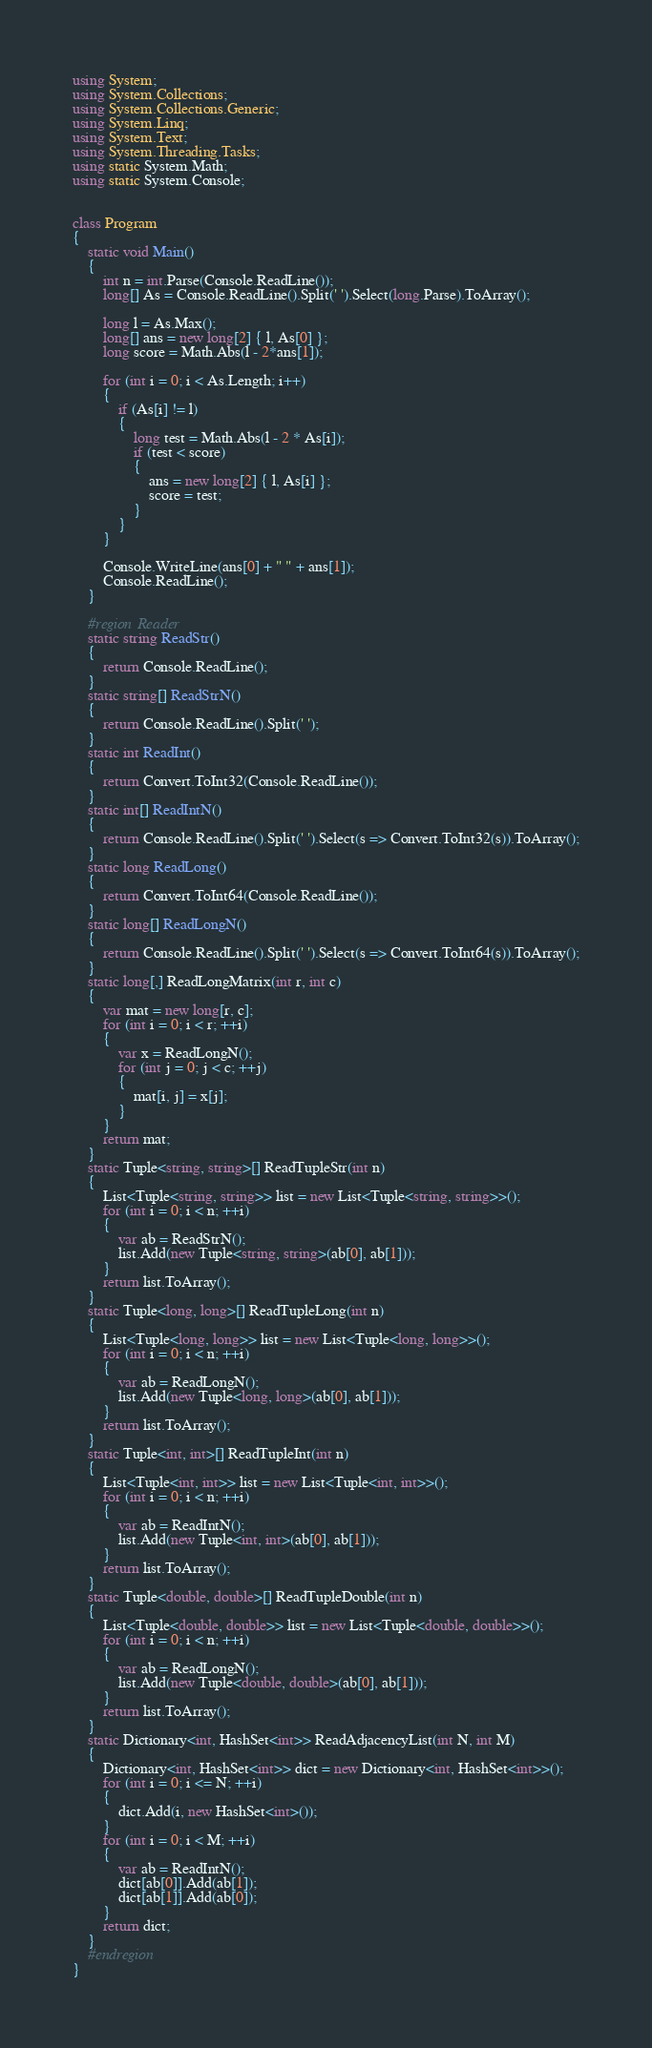Convert code to text. <code><loc_0><loc_0><loc_500><loc_500><_C#_>using System;
using System.Collections;
using System.Collections.Generic;
using System.Linq;
using System.Text;
using System.Threading.Tasks;
using static System.Math;
using static System.Console;


class Program
{
    static void Main()
    {
        int n = int.Parse(Console.ReadLine());
        long[] As = Console.ReadLine().Split(' ').Select(long.Parse).ToArray();

        long l = As.Max();
        long[] ans = new long[2] { l, As[0] };
        long score = Math.Abs(l - 2*ans[1]);

        for (int i = 0; i < As.Length; i++)
        {
            if (As[i] != l)
            {
                long test = Math.Abs(l - 2 * As[i]);
                if (test < score)
                {
                    ans = new long[2] { l, As[i] };
                    score = test;
                }
            }
        }

        Console.WriteLine(ans[0] + " " + ans[1]);
        Console.ReadLine();
    }

    #region Reader
    static string ReadStr()
    {
        return Console.ReadLine();
    }
    static string[] ReadStrN()
    {
        return Console.ReadLine().Split(' ');
    }
    static int ReadInt()
    {
        return Convert.ToInt32(Console.ReadLine());
    }
    static int[] ReadIntN()
    {
        return Console.ReadLine().Split(' ').Select(s => Convert.ToInt32(s)).ToArray();
    }
    static long ReadLong()
    {
        return Convert.ToInt64(Console.ReadLine());
    }
    static long[] ReadLongN()
    {
        return Console.ReadLine().Split(' ').Select(s => Convert.ToInt64(s)).ToArray();
    }
    static long[,] ReadLongMatrix(int r, int c)
    {
        var mat = new long[r, c];
        for (int i = 0; i < r; ++i)
        {
            var x = ReadLongN();
            for (int j = 0; j < c; ++j)
            {
                mat[i, j] = x[j];
            }
        }
        return mat;
    }
    static Tuple<string, string>[] ReadTupleStr(int n)
    {
        List<Tuple<string, string>> list = new List<Tuple<string, string>>();
        for (int i = 0; i < n; ++i)
        {
            var ab = ReadStrN();
            list.Add(new Tuple<string, string>(ab[0], ab[1]));
        }
        return list.ToArray();
    }
    static Tuple<long, long>[] ReadTupleLong(int n)
    {
        List<Tuple<long, long>> list = new List<Tuple<long, long>>();
        for (int i = 0; i < n; ++i)
        {
            var ab = ReadLongN();
            list.Add(new Tuple<long, long>(ab[0], ab[1]));
        }
        return list.ToArray();
    }
    static Tuple<int, int>[] ReadTupleInt(int n)
    {
        List<Tuple<int, int>> list = new List<Tuple<int, int>>();
        for (int i = 0; i < n; ++i)
        {
            var ab = ReadIntN();
            list.Add(new Tuple<int, int>(ab[0], ab[1]));
        }
        return list.ToArray();
    }
    static Tuple<double, double>[] ReadTupleDouble(int n)
    {
        List<Tuple<double, double>> list = new List<Tuple<double, double>>();
        for (int i = 0; i < n; ++i)
        {
            var ab = ReadLongN();
            list.Add(new Tuple<double, double>(ab[0], ab[1]));
        }
        return list.ToArray();
    }
    static Dictionary<int, HashSet<int>> ReadAdjacencyList(int N, int M)
    {
        Dictionary<int, HashSet<int>> dict = new Dictionary<int, HashSet<int>>();
        for (int i = 0; i <= N; ++i)
        {
            dict.Add(i, new HashSet<int>());
        }
        for (int i = 0; i < M; ++i)
        {
            var ab = ReadIntN();
            dict[ab[0]].Add(ab[1]);
            dict[ab[1]].Add(ab[0]);
        }
        return dict;
    }
    #endregion
}</code> 